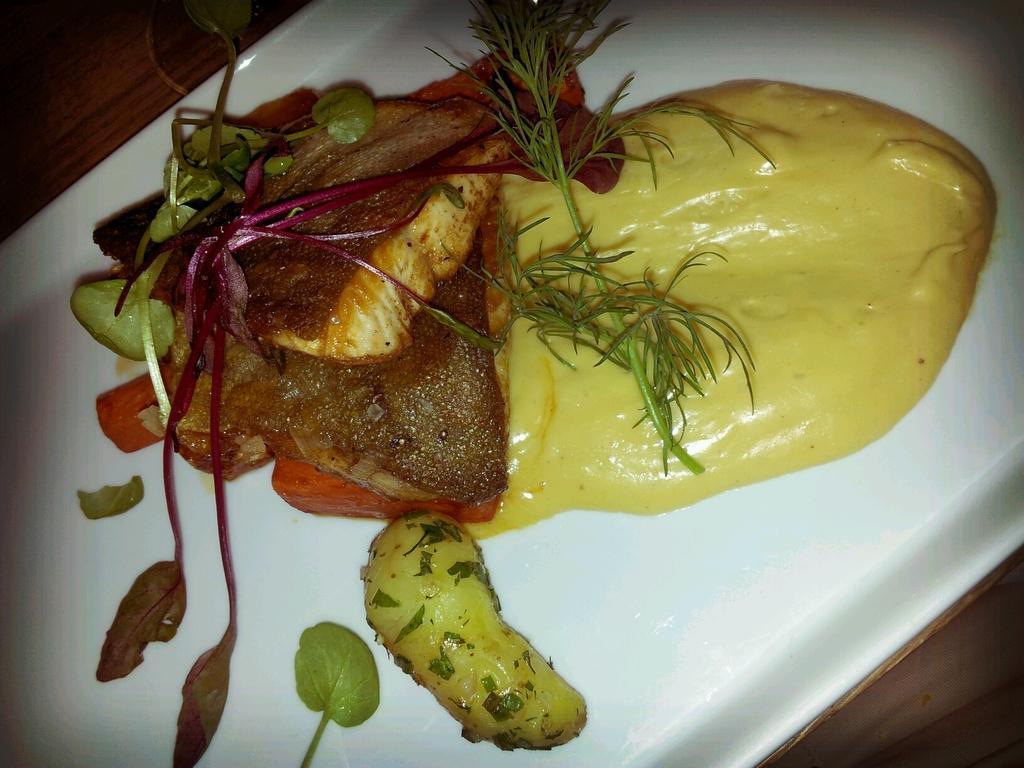How would you summarize this image in a sentence or two? In this picture there is a plate, it is served with food. The plate is placed on a table. 